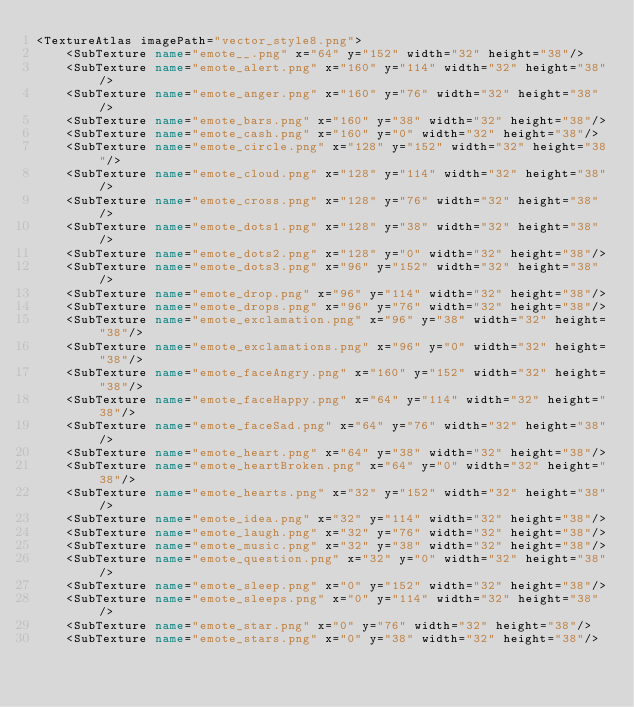Convert code to text. <code><loc_0><loc_0><loc_500><loc_500><_XML_><TextureAtlas imagePath="vector_style8.png">
	<SubTexture name="emote__.png" x="64" y="152" width="32" height="38"/>
	<SubTexture name="emote_alert.png" x="160" y="114" width="32" height="38"/>
	<SubTexture name="emote_anger.png" x="160" y="76" width="32" height="38"/>
	<SubTexture name="emote_bars.png" x="160" y="38" width="32" height="38"/>
	<SubTexture name="emote_cash.png" x="160" y="0" width="32" height="38"/>
	<SubTexture name="emote_circle.png" x="128" y="152" width="32" height="38"/>
	<SubTexture name="emote_cloud.png" x="128" y="114" width="32" height="38"/>
	<SubTexture name="emote_cross.png" x="128" y="76" width="32" height="38"/>
	<SubTexture name="emote_dots1.png" x="128" y="38" width="32" height="38"/>
	<SubTexture name="emote_dots2.png" x="128" y="0" width="32" height="38"/>
	<SubTexture name="emote_dots3.png" x="96" y="152" width="32" height="38"/>
	<SubTexture name="emote_drop.png" x="96" y="114" width="32" height="38"/>
	<SubTexture name="emote_drops.png" x="96" y="76" width="32" height="38"/>
	<SubTexture name="emote_exclamation.png" x="96" y="38" width="32" height="38"/>
	<SubTexture name="emote_exclamations.png" x="96" y="0" width="32" height="38"/>
	<SubTexture name="emote_faceAngry.png" x="160" y="152" width="32" height="38"/>
	<SubTexture name="emote_faceHappy.png" x="64" y="114" width="32" height="38"/>
	<SubTexture name="emote_faceSad.png" x="64" y="76" width="32" height="38"/>
	<SubTexture name="emote_heart.png" x="64" y="38" width="32" height="38"/>
	<SubTexture name="emote_heartBroken.png" x="64" y="0" width="32" height="38"/>
	<SubTexture name="emote_hearts.png" x="32" y="152" width="32" height="38"/>
	<SubTexture name="emote_idea.png" x="32" y="114" width="32" height="38"/>
	<SubTexture name="emote_laugh.png" x="32" y="76" width="32" height="38"/>
	<SubTexture name="emote_music.png" x="32" y="38" width="32" height="38"/>
	<SubTexture name="emote_question.png" x="32" y="0" width="32" height="38"/>
	<SubTexture name="emote_sleep.png" x="0" y="152" width="32" height="38"/>
	<SubTexture name="emote_sleeps.png" x="0" y="114" width="32" height="38"/>
	<SubTexture name="emote_star.png" x="0" y="76" width="32" height="38"/>
	<SubTexture name="emote_stars.png" x="0" y="38" width="32" height="38"/></code> 